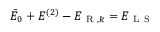<formula> <loc_0><loc_0><loc_500><loc_500>\bar { E } _ { 0 } + E ^ { ( 2 ) } - E _ { R , k } = E _ { L S }</formula> 